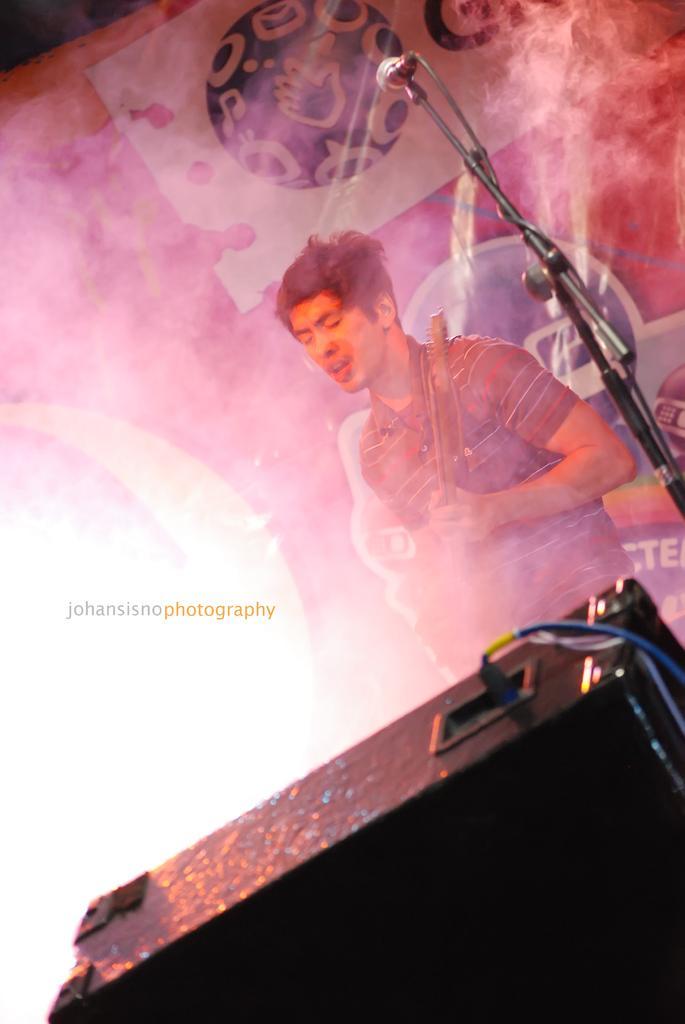How would you summarize this image in a sentence or two? In this image I can see a person standing and holding something. I can see a mic,stand,speaker,wire and colorful banner at the back. 